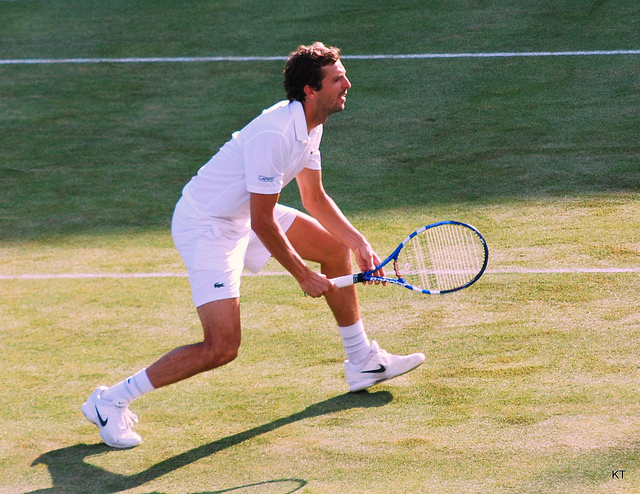<image>Is he waiting for a Shuttlecock? I don't know if he is waiting for a Shuttlecock. Is he waiting for a Shuttlecock? I don't know if he is waiting for a Shuttlecock. It seems like he is not waiting for a Shuttlecock. 